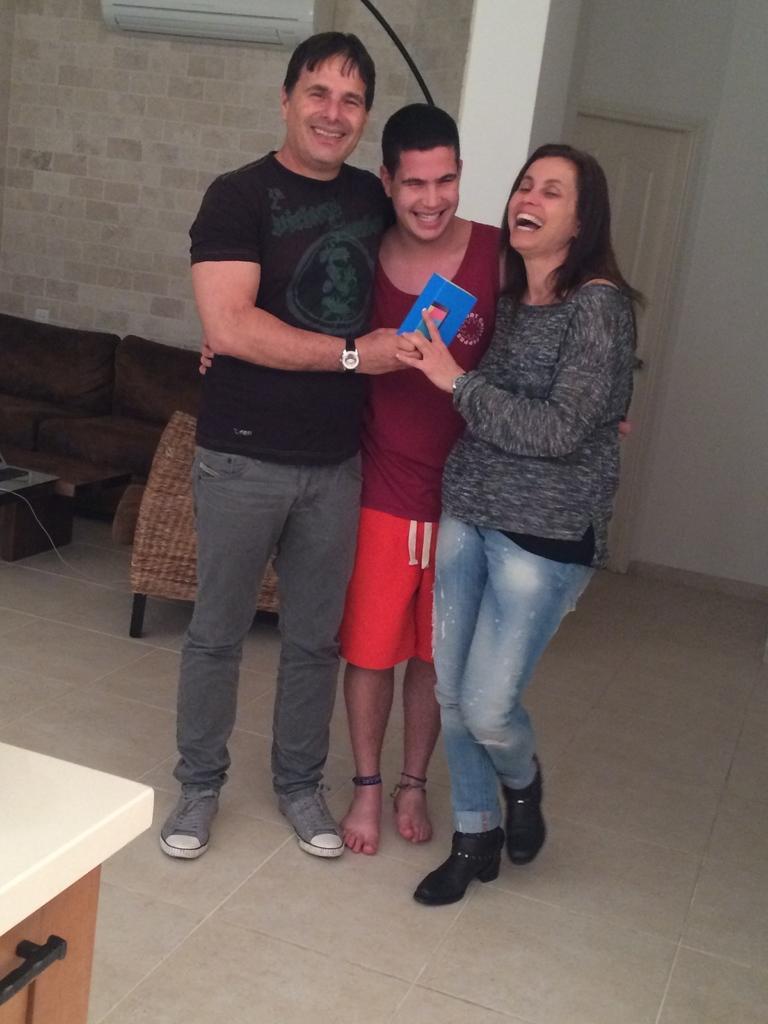Could you give a brief overview of what you see in this image? In this picture a man is standing and he is smiling, and beside him a person is standing he is wearing red t-shirt, and beside him a woman is standing and she is smiling. here is the floor and here is the table, sofa here is the wall made of bricks,and here is the ac there is the pillar. 